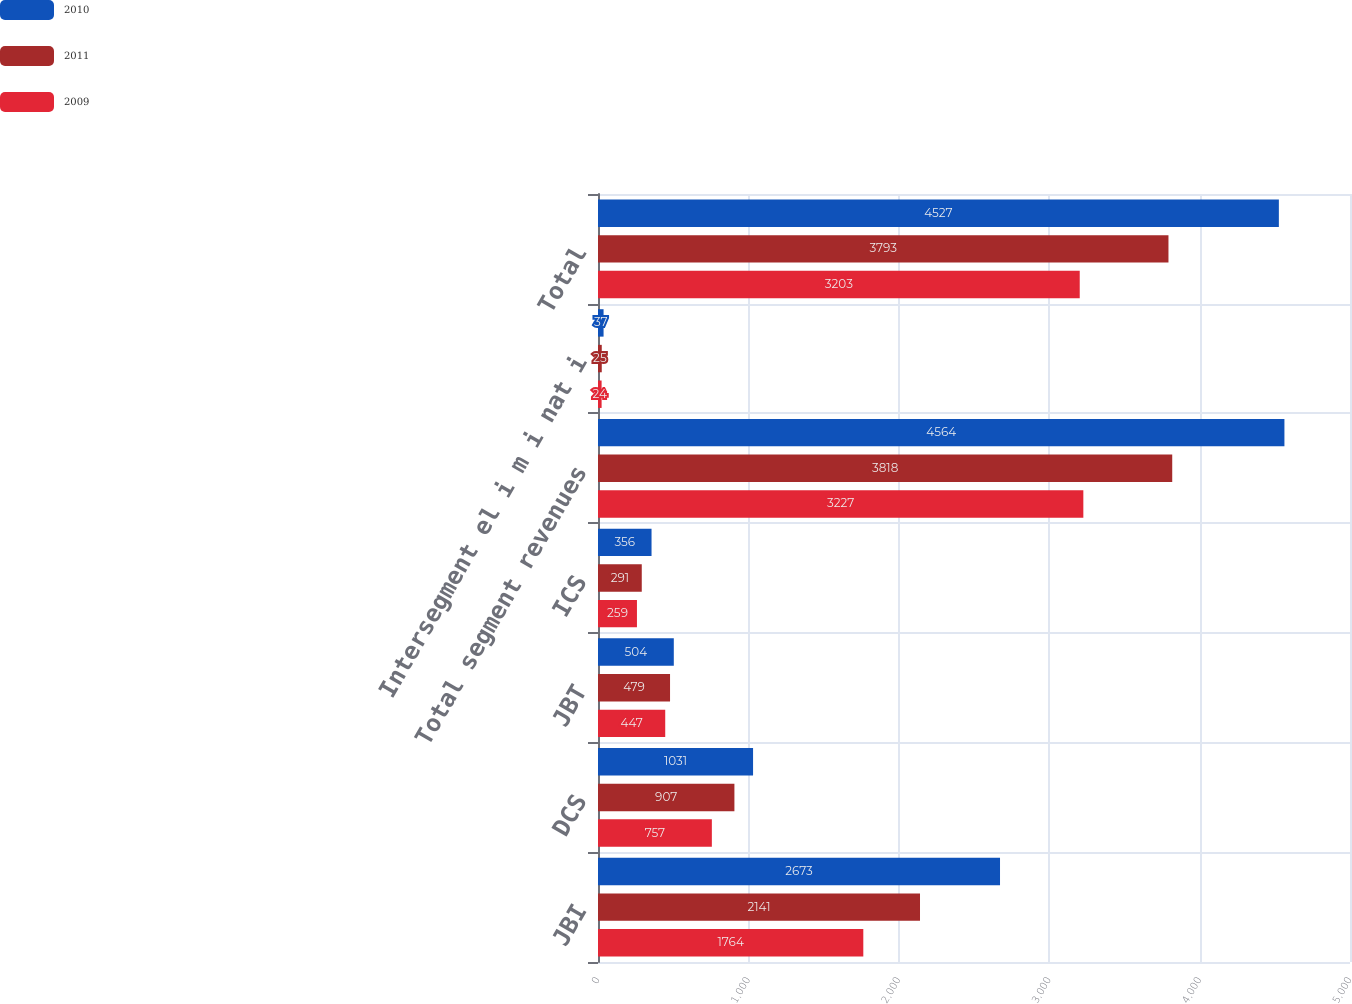<chart> <loc_0><loc_0><loc_500><loc_500><stacked_bar_chart><ecel><fcel>JBI<fcel>DCS<fcel>JBT<fcel>ICS<fcel>Total segment revenues<fcel>Intersegment el i m i nat i<fcel>Total<nl><fcel>2010<fcel>2673<fcel>1031<fcel>504<fcel>356<fcel>4564<fcel>37<fcel>4527<nl><fcel>2011<fcel>2141<fcel>907<fcel>479<fcel>291<fcel>3818<fcel>25<fcel>3793<nl><fcel>2009<fcel>1764<fcel>757<fcel>447<fcel>259<fcel>3227<fcel>24<fcel>3203<nl></chart> 